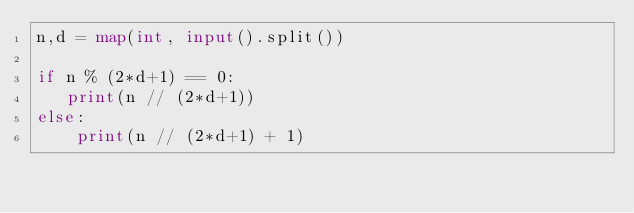Convert code to text. <code><loc_0><loc_0><loc_500><loc_500><_Python_>n,d = map(int, input().split())

if n % (2*d+1) == 0:
   print(n // (2*d+1))
else:
    print(n // (2*d+1) + 1)</code> 